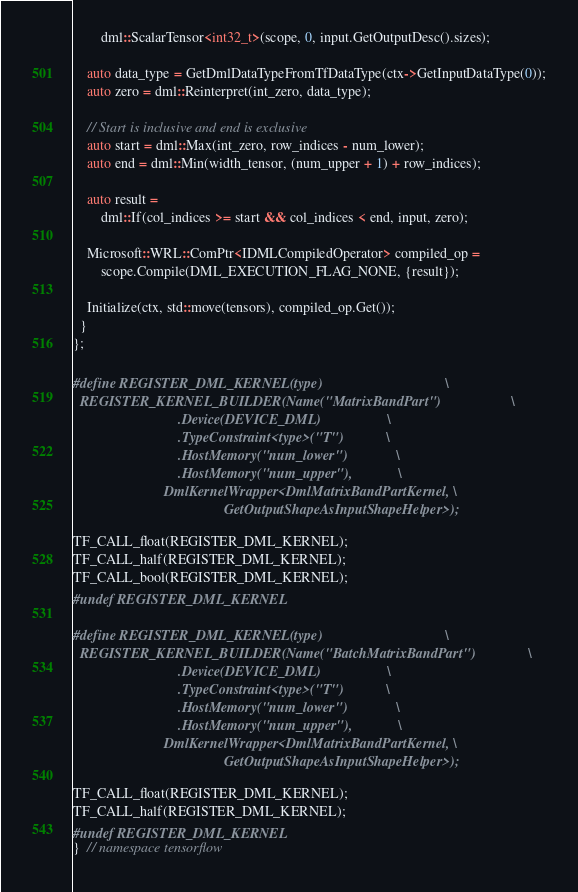Convert code to text. <code><loc_0><loc_0><loc_500><loc_500><_C++_>        dml::ScalarTensor<int32_t>(scope, 0, input.GetOutputDesc().sizes);

    auto data_type = GetDmlDataTypeFromTfDataType(ctx->GetInputDataType(0));
    auto zero = dml::Reinterpret(int_zero, data_type);

    // Start is inclusive and end is exclusive
    auto start = dml::Max(int_zero, row_indices - num_lower);
    auto end = dml::Min(width_tensor, (num_upper + 1) + row_indices);

    auto result =
        dml::If(col_indices >= start && col_indices < end, input, zero);

    Microsoft::WRL::ComPtr<IDMLCompiledOperator> compiled_op =
        scope.Compile(DML_EXECUTION_FLAG_NONE, {result});

    Initialize(ctx, std::move(tensors), compiled_op.Get());
  }
};

#define REGISTER_DML_KERNEL(type)                                   \
  REGISTER_KERNEL_BUILDER(Name("MatrixBandPart")                    \
                              .Device(DEVICE_DML)                   \
                              .TypeConstraint<type>("T")            \
                              .HostMemory("num_lower")              \
                              .HostMemory("num_upper"),             \
                          DmlKernelWrapper<DmlMatrixBandPartKernel, \
                                           GetOutputShapeAsInputShapeHelper>);

TF_CALL_float(REGISTER_DML_KERNEL);
TF_CALL_half(REGISTER_DML_KERNEL);
TF_CALL_bool(REGISTER_DML_KERNEL);
#undef REGISTER_DML_KERNEL

#define REGISTER_DML_KERNEL(type)                                   \
  REGISTER_KERNEL_BUILDER(Name("BatchMatrixBandPart")               \
                              .Device(DEVICE_DML)                   \
                              .TypeConstraint<type>("T")            \
                              .HostMemory("num_lower")              \
                              .HostMemory("num_upper"),             \
                          DmlKernelWrapper<DmlMatrixBandPartKernel, \
                                           GetOutputShapeAsInputShapeHelper>);

TF_CALL_float(REGISTER_DML_KERNEL);
TF_CALL_half(REGISTER_DML_KERNEL);
#undef REGISTER_DML_KERNEL
}  // namespace tensorflow</code> 